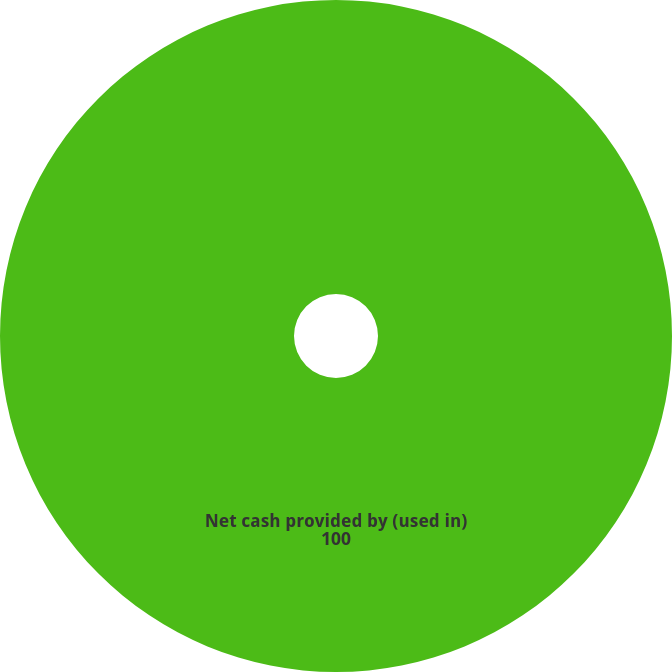<chart> <loc_0><loc_0><loc_500><loc_500><pie_chart><fcel>Net cash provided by (used in)<nl><fcel>100.0%<nl></chart> 